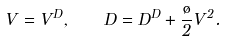Convert formula to latex. <formula><loc_0><loc_0><loc_500><loc_500>V = V ^ { D } , \quad D = D ^ { D } + \frac { \tau } { 2 } V ^ { 2 } .</formula> 